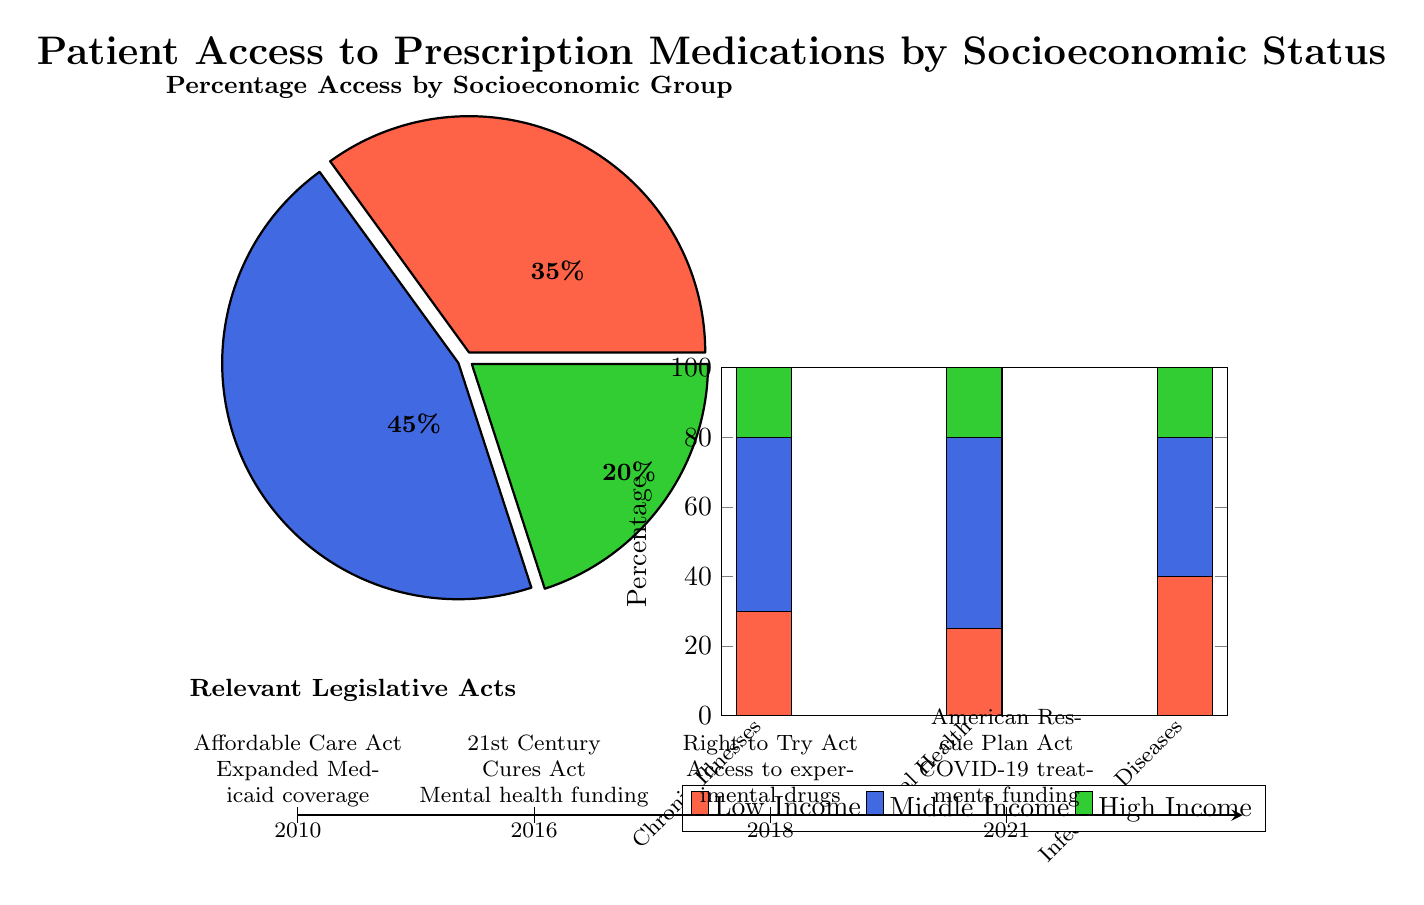What percentage of Low Income individuals have access to prescription medications? The pie chart indicates that 35% of access to prescription medications is attributed to Low Income individuals.
Answer: 35% How does the percentage of Middle Income access to prescription medications compare to Low Income access? The pie chart shows that Middle Income access is 45%, which is 10% higher than Low Income access of 35%.
Answer: 10% higher What condition has the highest percentage of access for Low Income individuals? In the histogram, the highest percentage represented for Low Income individuals is 40% for Infectious Diseases.
Answer: Infectious Diseases Which socioeconomic group has the lowest overall access to prescription medications? Referring to the pie chart, the Low Income group at 35% represents the lowest overall access to prescription medications compared to Middle Income and High Income groups.
Answer: Low Income What is the total percentage of access for High Income individuals across all conditions? In the histogram, the access for High Income individuals sums up to 20% for Chronic Illnesses, 20% for Mental Health, and 20% for Infectious Diseases, giving a total access percentage of 60%.
Answer: 60% Which legislative act is associated with a timeline point in 2016? The timeline indicates that the 21st Century Cures Act, focused on mental health funding, aligns with the year 2016.
Answer: 21st Century Cures Act What percentage of access is attributed to Chronic Illnesses for Middle Income individuals? The histogram indicates that the percentage of access attributed to Chronic Illnesses for Middle Income individuals is 50%.
Answer: 50% How many legislative acts are indicated in the timeline? The timeline displays four distinct legislative acts listed, one for each timeline point.
Answer: Four 